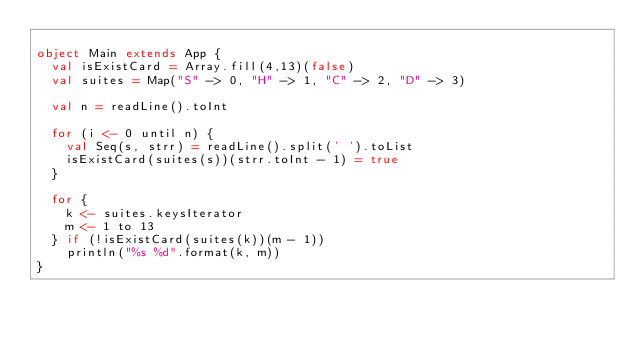<code> <loc_0><loc_0><loc_500><loc_500><_Scala_>
object Main extends App {
  val isExistCard = Array.fill(4,13)(false)
  val suites = Map("S" -> 0, "H" -> 1, "C" -> 2, "D" -> 3)

  val n = readLine().toInt

  for (i <- 0 until n) {
    val Seq(s, strr) = readLine().split(' ').toList
    isExistCard(suites(s))(strr.toInt - 1) = true
  }

  for {
    k <- suites.keysIterator
    m <- 1 to 13
  } if (!isExistCard(suites(k))(m - 1))
    println("%s %d".format(k, m))
}

</code> 